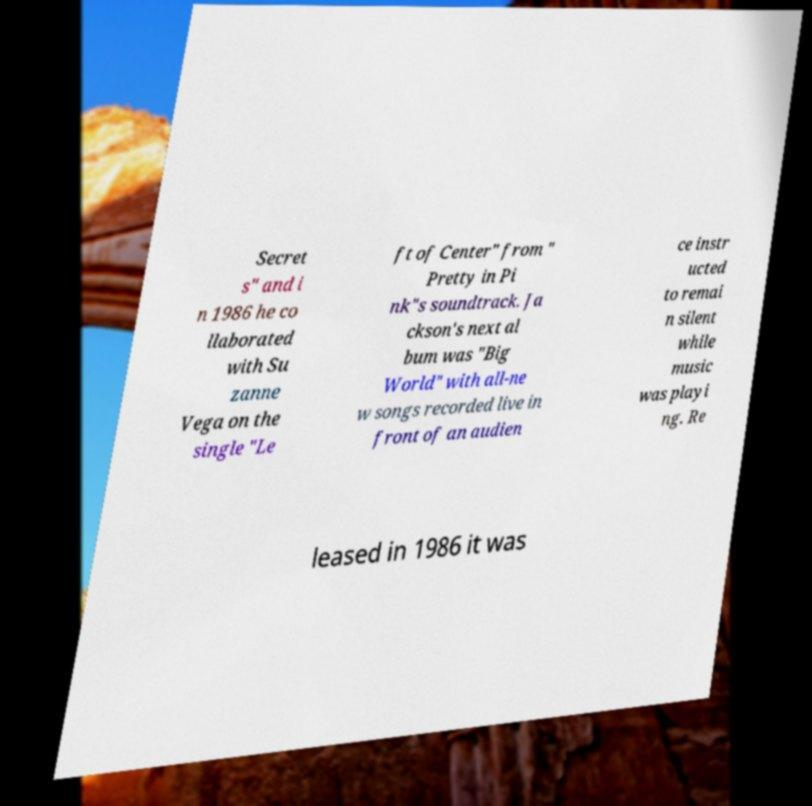Please read and relay the text visible in this image. What does it say? Secret s" and i n 1986 he co llaborated with Su zanne Vega on the single "Le ft of Center" from " Pretty in Pi nk"s soundtrack. Ja ckson's next al bum was "Big World" with all-ne w songs recorded live in front of an audien ce instr ucted to remai n silent while music was playi ng. Re leased in 1986 it was 